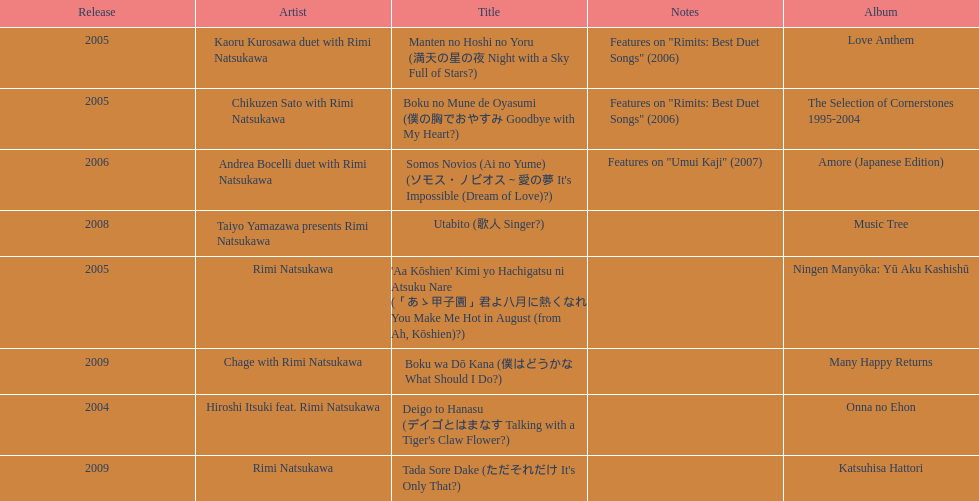What year was the first title released? 2004. 